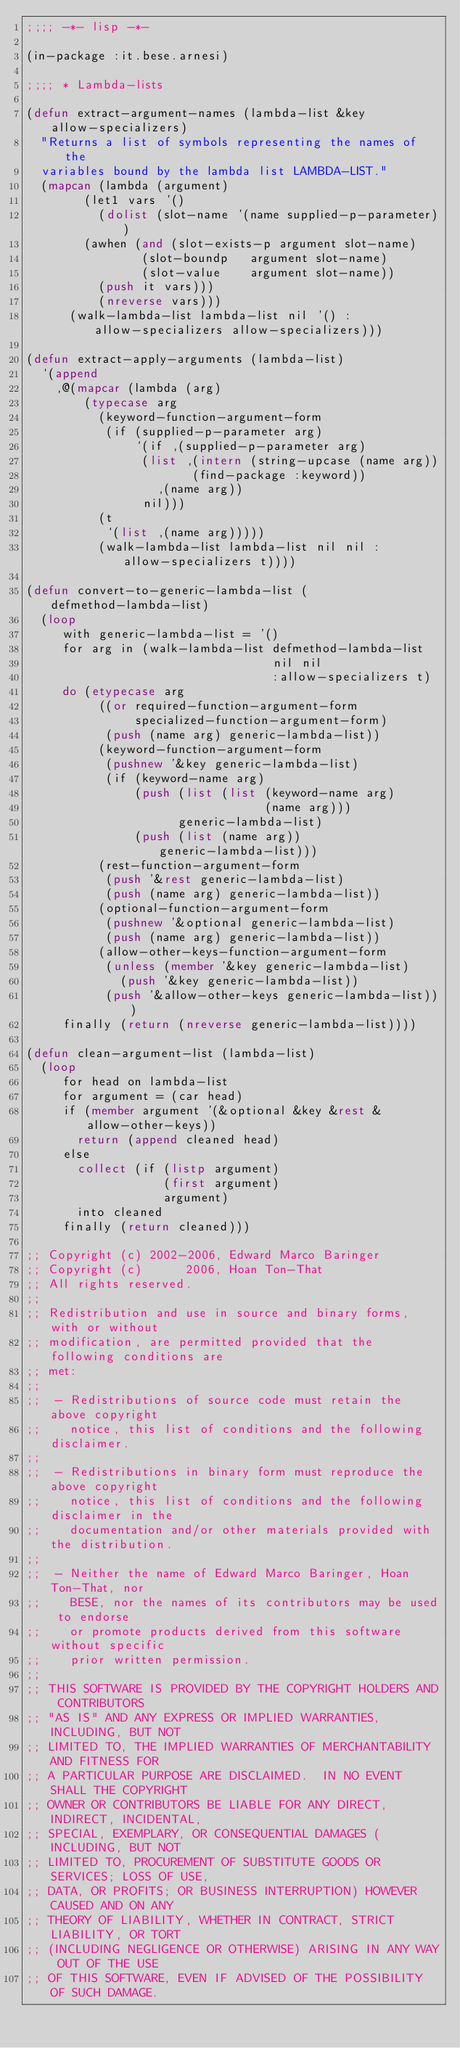<code> <loc_0><loc_0><loc_500><loc_500><_Lisp_>;;;; -*- lisp -*-

(in-package :it.bese.arnesi)

;;;; * Lambda-lists

(defun extract-argument-names (lambda-list &key allow-specializers)
  "Returns a list of symbols representing the names of the
  variables bound by the lambda list LAMBDA-LIST."
  (mapcan (lambda (argument)
	    (let1 vars '()
	      (dolist (slot-name '(name supplied-p-parameter))
		(awhen (and (slot-exists-p argument slot-name)
			    (slot-boundp   argument slot-name)
			    (slot-value    argument slot-name))
		  (push it vars)))
	      (nreverse vars)))
	  (walk-lambda-list lambda-list nil '() :allow-specializers allow-specializers)))

(defun extract-apply-arguments (lambda-list)
  `(append
    ,@(mapcar (lambda (arg)
		(typecase arg
		  (keyword-function-argument-form
		   (if (supplied-p-parameter arg)
		       `(if ,(supplied-p-parameter arg)
			    (list ,(intern (string-upcase (name arg))
					   (find-package :keyword))
				  ,(name arg))
			    nil)))
		  (t
		   `(list ,(name arg)))))
	      (walk-lambda-list lambda-list nil nil :allow-specializers t))))

(defun convert-to-generic-lambda-list (defmethod-lambda-list)
  (loop
     with generic-lambda-list = '()
     for arg in (walk-lambda-list defmethod-lambda-list
                                  nil nil
                                  :allow-specializers t)
     do (etypecase arg
          ((or required-function-argument-form
               specialized-function-argument-form)
           (push (name arg) generic-lambda-list))
          (keyword-function-argument-form
           (pushnew '&key generic-lambda-list)
           (if (keyword-name arg)
               (push (list (list (keyword-name arg)
                                 (name arg)))
                     generic-lambda-list)
               (push (list (name arg)) generic-lambda-list)))
          (rest-function-argument-form
           (push '&rest generic-lambda-list)
           (push (name arg) generic-lambda-list))
          (optional-function-argument-form
           (pushnew '&optional generic-lambda-list)
           (push (name arg) generic-lambda-list))
          (allow-other-keys-function-argument-form
           (unless (member '&key generic-lambda-list)
             (push '&key generic-lambda-list))
           (push '&allow-other-keys generic-lambda-list)))
     finally (return (nreverse generic-lambda-list))))

(defun clean-argument-list (lambda-list)
  (loop
     for head on lambda-list
     for argument = (car head)
     if (member argument '(&optional &key &rest &allow-other-keys))
       return (append cleaned head)
     else
       collect (if (listp argument)
                   (first argument)
                   argument)
       into cleaned
     finally (return cleaned)))

;; Copyright (c) 2002-2006, Edward Marco Baringer
;; Copyright (c)      2006, Hoan Ton-That
;; All rights reserved. 
;; 
;; Redistribution and use in source and binary forms, with or without
;; modification, are permitted provided that the following conditions are
;; met:
;; 
;;  - Redistributions of source code must retain the above copyright
;;    notice, this list of conditions and the following disclaimer.
;; 
;;  - Redistributions in binary form must reproduce the above copyright
;;    notice, this list of conditions and the following disclaimer in the
;;    documentation and/or other materials provided with the distribution.
;;
;;  - Neither the name of Edward Marco Baringer, Hoan Ton-That, nor
;;    BESE, nor the names of its contributors may be used to endorse
;;    or promote products derived from this software without specific
;;    prior written permission.
;; 
;; THIS SOFTWARE IS PROVIDED BY THE COPYRIGHT HOLDERS AND CONTRIBUTORS
;; "AS IS" AND ANY EXPRESS OR IMPLIED WARRANTIES, INCLUDING, BUT NOT
;; LIMITED TO, THE IMPLIED WARRANTIES OF MERCHANTABILITY AND FITNESS FOR
;; A PARTICULAR PURPOSE ARE DISCLAIMED.  IN NO EVENT SHALL THE COPYRIGHT
;; OWNER OR CONTRIBUTORS BE LIABLE FOR ANY DIRECT, INDIRECT, INCIDENTAL,
;; SPECIAL, EXEMPLARY, OR CONSEQUENTIAL DAMAGES (INCLUDING, BUT NOT
;; LIMITED TO, PROCUREMENT OF SUBSTITUTE GOODS OR SERVICES; LOSS OF USE,
;; DATA, OR PROFITS; OR BUSINESS INTERRUPTION) HOWEVER CAUSED AND ON ANY
;; THEORY OF LIABILITY, WHETHER IN CONTRACT, STRICT LIABILITY, OR TORT
;; (INCLUDING NEGLIGENCE OR OTHERWISE) ARISING IN ANY WAY OUT OF THE USE
;; OF THIS SOFTWARE, EVEN IF ADVISED OF THE POSSIBILITY OF SUCH DAMAGE.
</code> 